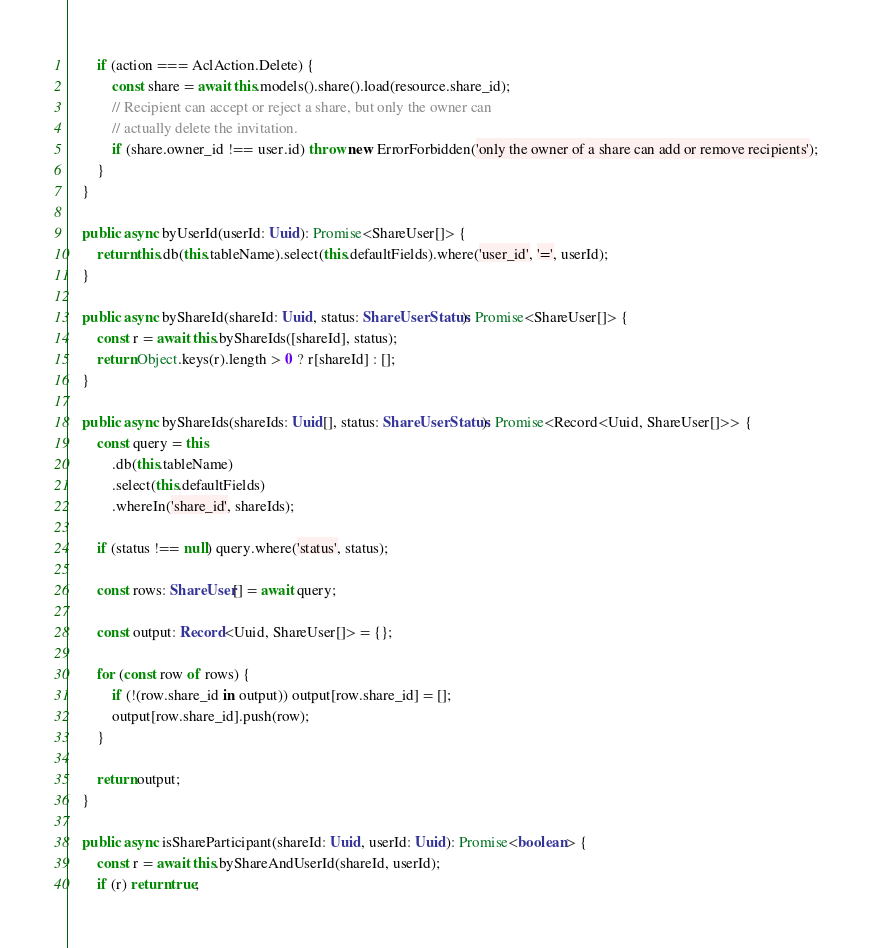Convert code to text. <code><loc_0><loc_0><loc_500><loc_500><_TypeScript_>
		if (action === AclAction.Delete) {
			const share = await this.models().share().load(resource.share_id);
			// Recipient can accept or reject a share, but only the owner can
			// actually delete the invitation.
			if (share.owner_id !== user.id) throw new ErrorForbidden('only the owner of a share can add or remove recipients');
		}
	}

	public async byUserId(userId: Uuid): Promise<ShareUser[]> {
		return this.db(this.tableName).select(this.defaultFields).where('user_id', '=', userId);
	}

	public async byShareId(shareId: Uuid, status: ShareUserStatus): Promise<ShareUser[]> {
		const r = await this.byShareIds([shareId], status);
		return Object.keys(r).length > 0 ? r[shareId] : [];
	}

	public async byShareIds(shareIds: Uuid[], status: ShareUserStatus): Promise<Record<Uuid, ShareUser[]>> {
		const query = this
			.db(this.tableName)
			.select(this.defaultFields)
			.whereIn('share_id', shareIds);

		if (status !== null) query.where('status', status);

		const rows: ShareUser[] = await query;

		const output: Record<Uuid, ShareUser[]> = {};

		for (const row of rows) {
			if (!(row.share_id in output)) output[row.share_id] = [];
			output[row.share_id].push(row);
		}

		return output;
	}

	public async isShareParticipant(shareId: Uuid, userId: Uuid): Promise<boolean> {
		const r = await this.byShareAndUserId(shareId, userId);
		if (r) return true;</code> 